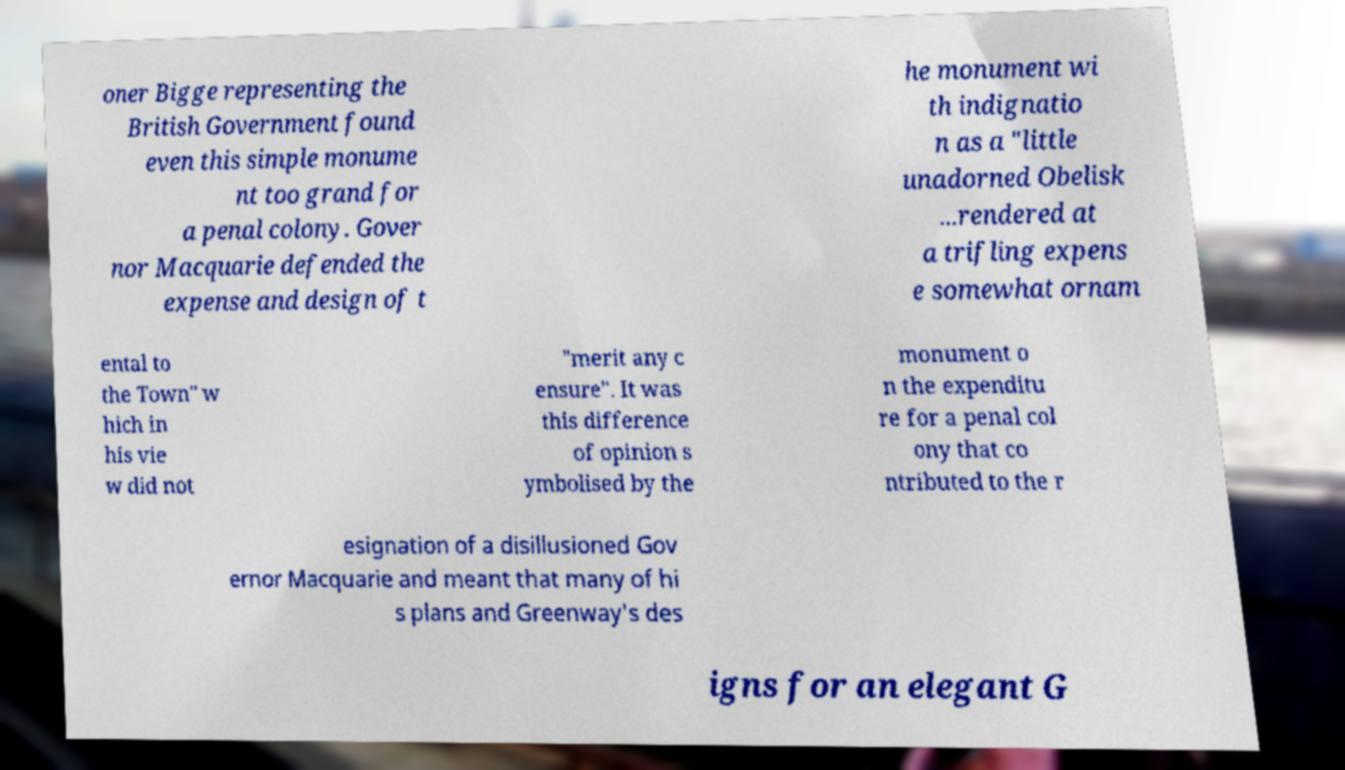Please read and relay the text visible in this image. What does it say? oner Bigge representing the British Government found even this simple monume nt too grand for a penal colony. Gover nor Macquarie defended the expense and design of t he monument wi th indignatio n as a "little unadorned Obelisk ...rendered at a trifling expens e somewhat ornam ental to the Town" w hich in his vie w did not "merit any c ensure". It was this difference of opinion s ymbolised by the monument o n the expenditu re for a penal col ony that co ntributed to the r esignation of a disillusioned Gov ernor Macquarie and meant that many of hi s plans and Greenway's des igns for an elegant G 